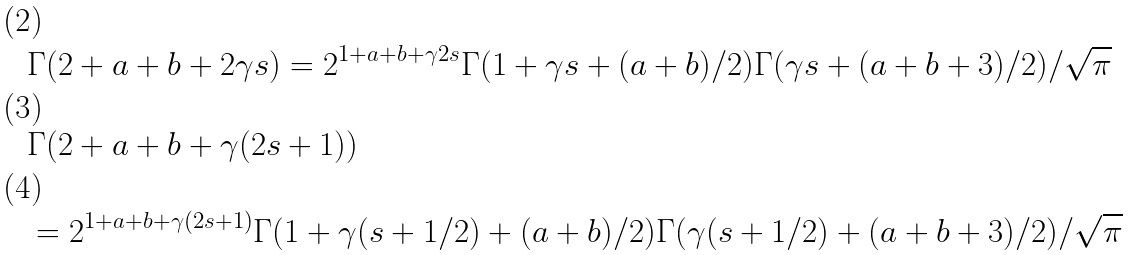<formula> <loc_0><loc_0><loc_500><loc_500>& \Gamma ( 2 + a + b + 2 \gamma s ) = 2 ^ { 1 + a + b + \gamma 2 s } \Gamma ( 1 + \gamma s + ( a + b ) / 2 ) \Gamma ( \gamma s + ( a + b + 3 ) / 2 ) / \sqrt { \pi } \\ & \Gamma ( 2 + a + b + \gamma ( 2 s + 1 ) ) \\ & = 2 ^ { 1 + a + b + \gamma ( 2 s + 1 ) } \Gamma ( 1 + \gamma ( s + 1 / 2 ) + ( a + b ) / 2 ) \Gamma ( \gamma ( s + 1 / 2 ) + ( a + b + 3 ) / 2 ) / \sqrt { \pi }</formula> 